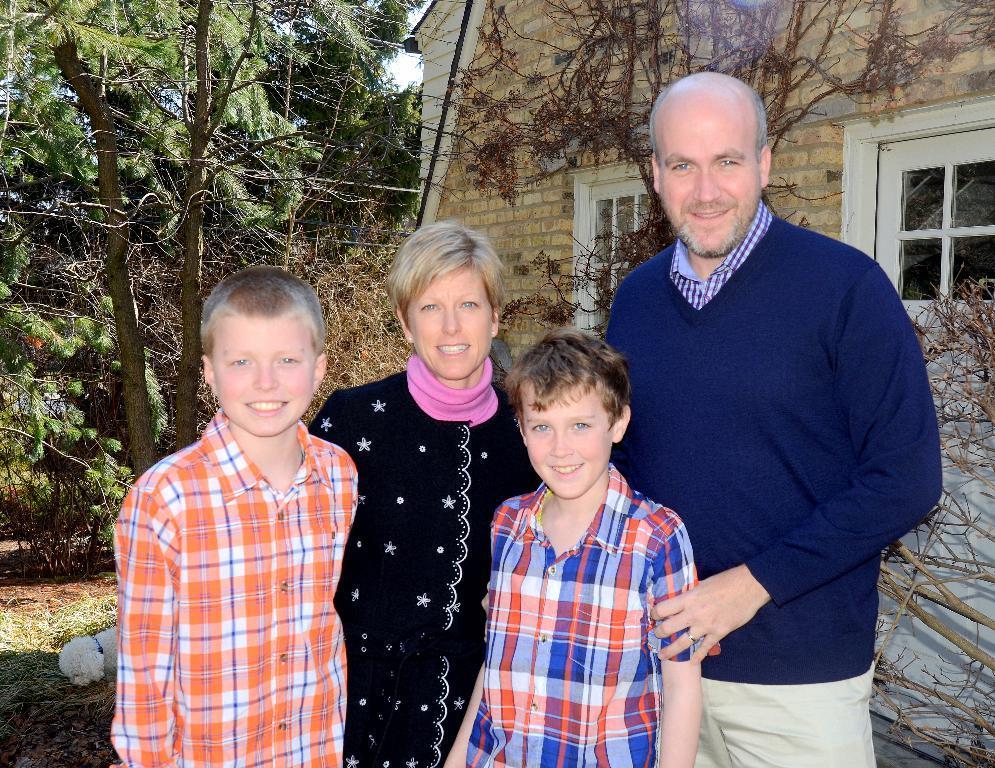In one or two sentences, can you explain what this image depicts? In this picture there are group of persons standing in the center and smiling. In the background there is a building and there are trees. On the ground there is grass. On the right side in front of the building there is a dry tree and there are windows which are white and colour. 